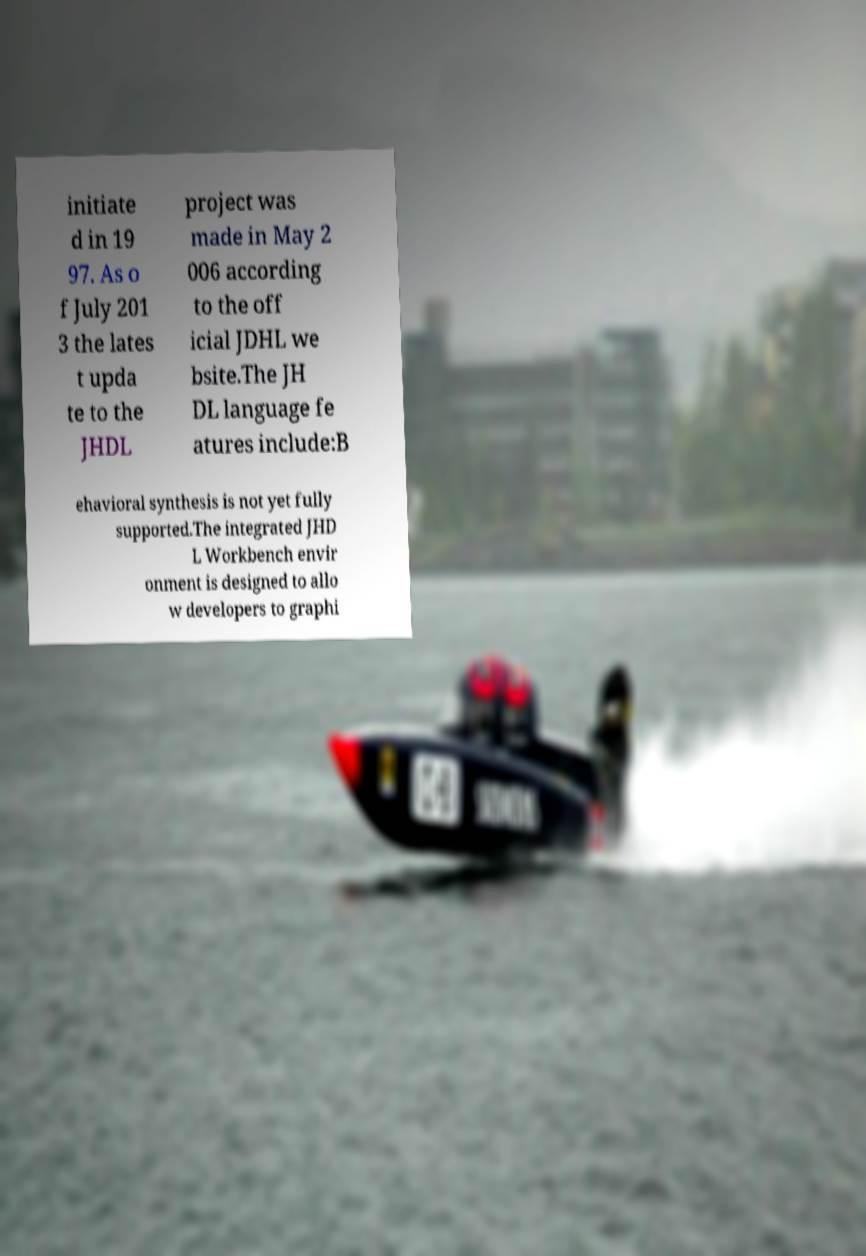There's text embedded in this image that I need extracted. Can you transcribe it verbatim? initiate d in 19 97. As o f July 201 3 the lates t upda te to the JHDL project was made in May 2 006 according to the off icial JDHL we bsite.The JH DL language fe atures include:B ehavioral synthesis is not yet fully supported.The integrated JHD L Workbench envir onment is designed to allo w developers to graphi 